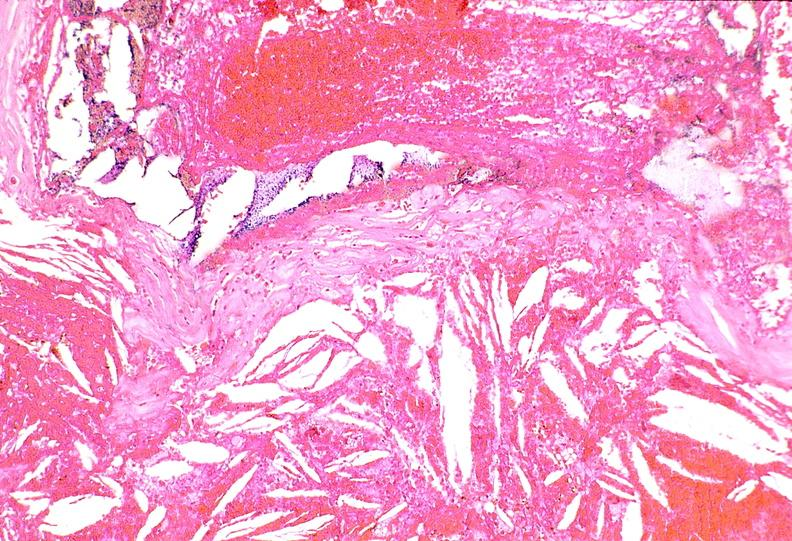does conjoined twins show right coronary artery, atherosclerosis and acute thrombus?
Answer the question using a single word or phrase. No 